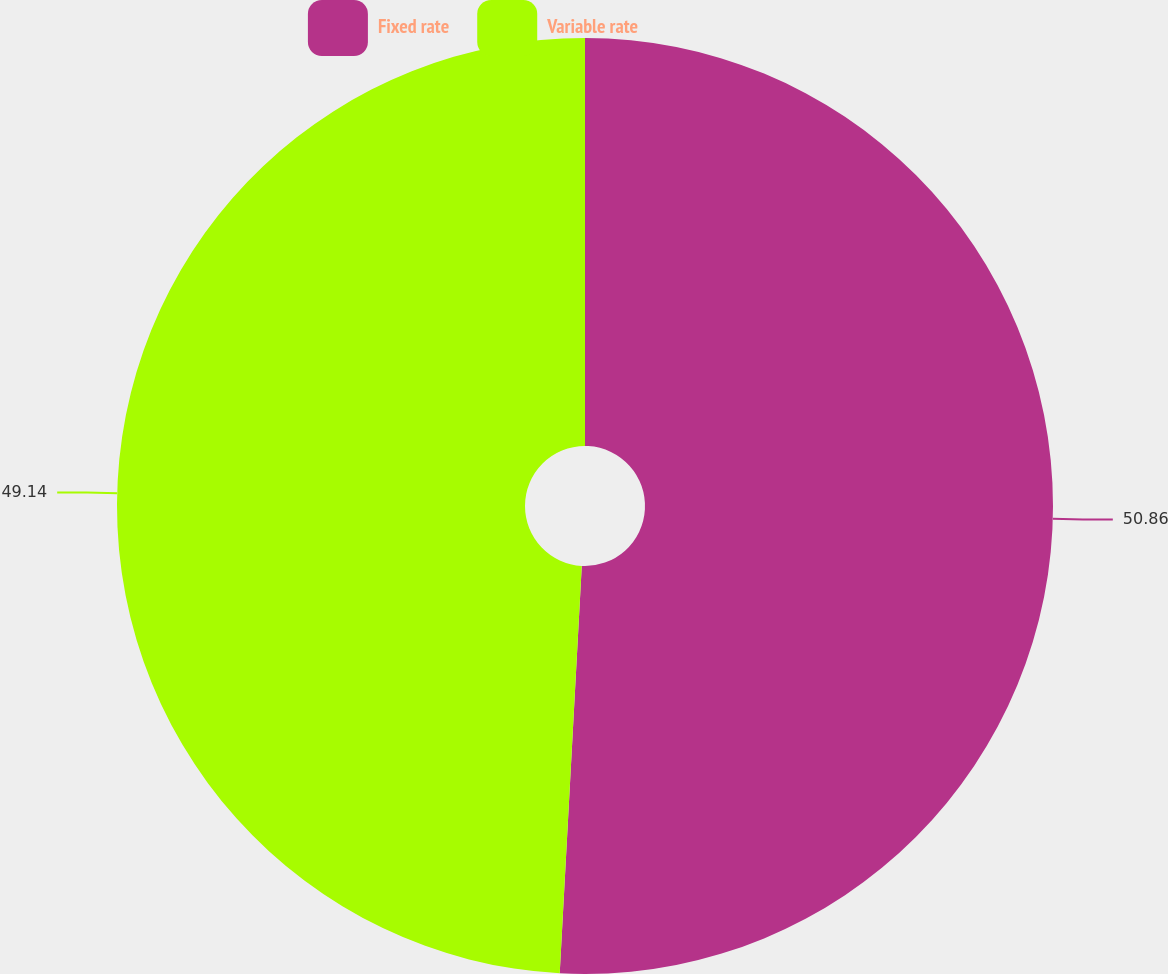<chart> <loc_0><loc_0><loc_500><loc_500><pie_chart><fcel>Fixed rate<fcel>Variable rate<nl><fcel>50.86%<fcel>49.14%<nl></chart> 